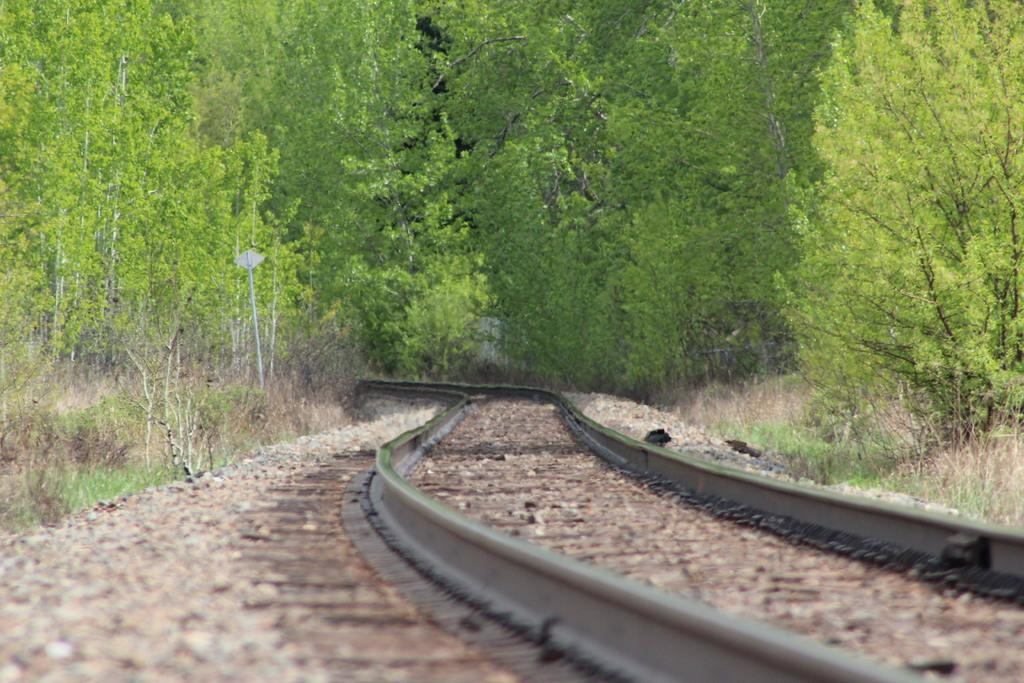What is located at the bottom of the image? There is a train track at the bottom of the image. What can be seen on either side of the train track? There are plants and trees on either side of the track. What type of quilt is draped over the train track in the image? There is no quilt present in the image; it features a train track with plants and trees on either side. What force is acting on the train track in the image? There is no force acting on the train track in the image; it is stationary and not in motion. 